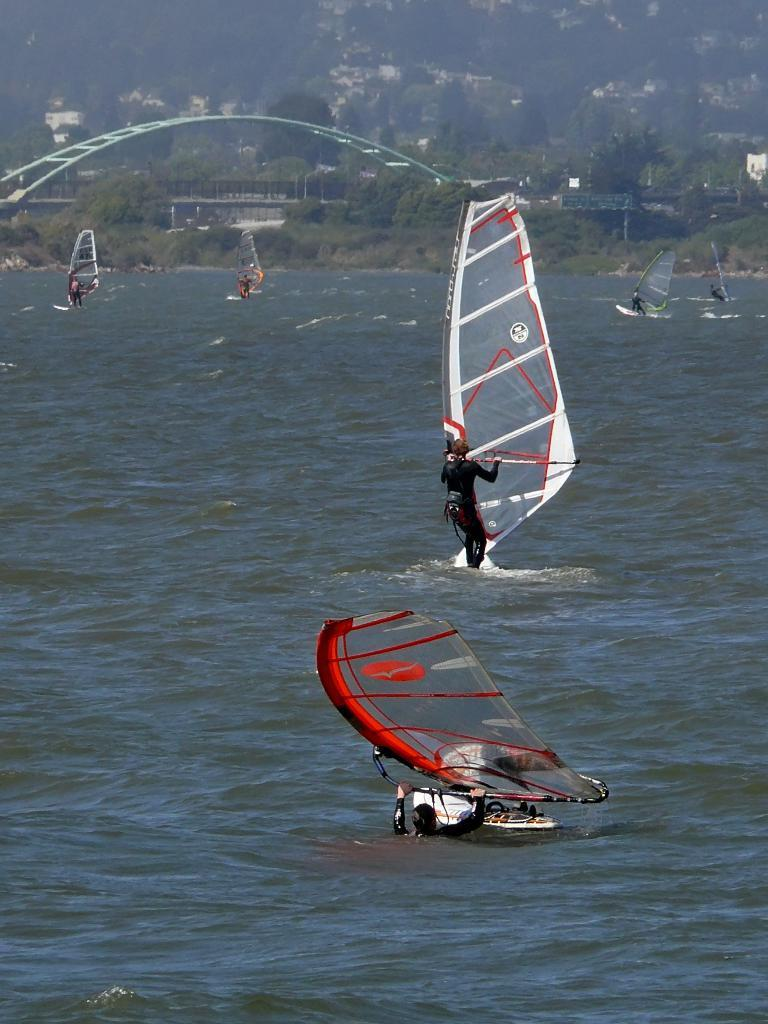Who or what can be seen in the image? There are people in the image. What is the primary setting or environment in the image? There is water visible in the image. What type of vegetation is present in the image? There are trees in the image. What type of hat is the person wearing in the image? There is no hat visible in the image; the people are not wearing any headwear. 